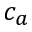Convert formula to latex. <formula><loc_0><loc_0><loc_500><loc_500>c _ { a }</formula> 